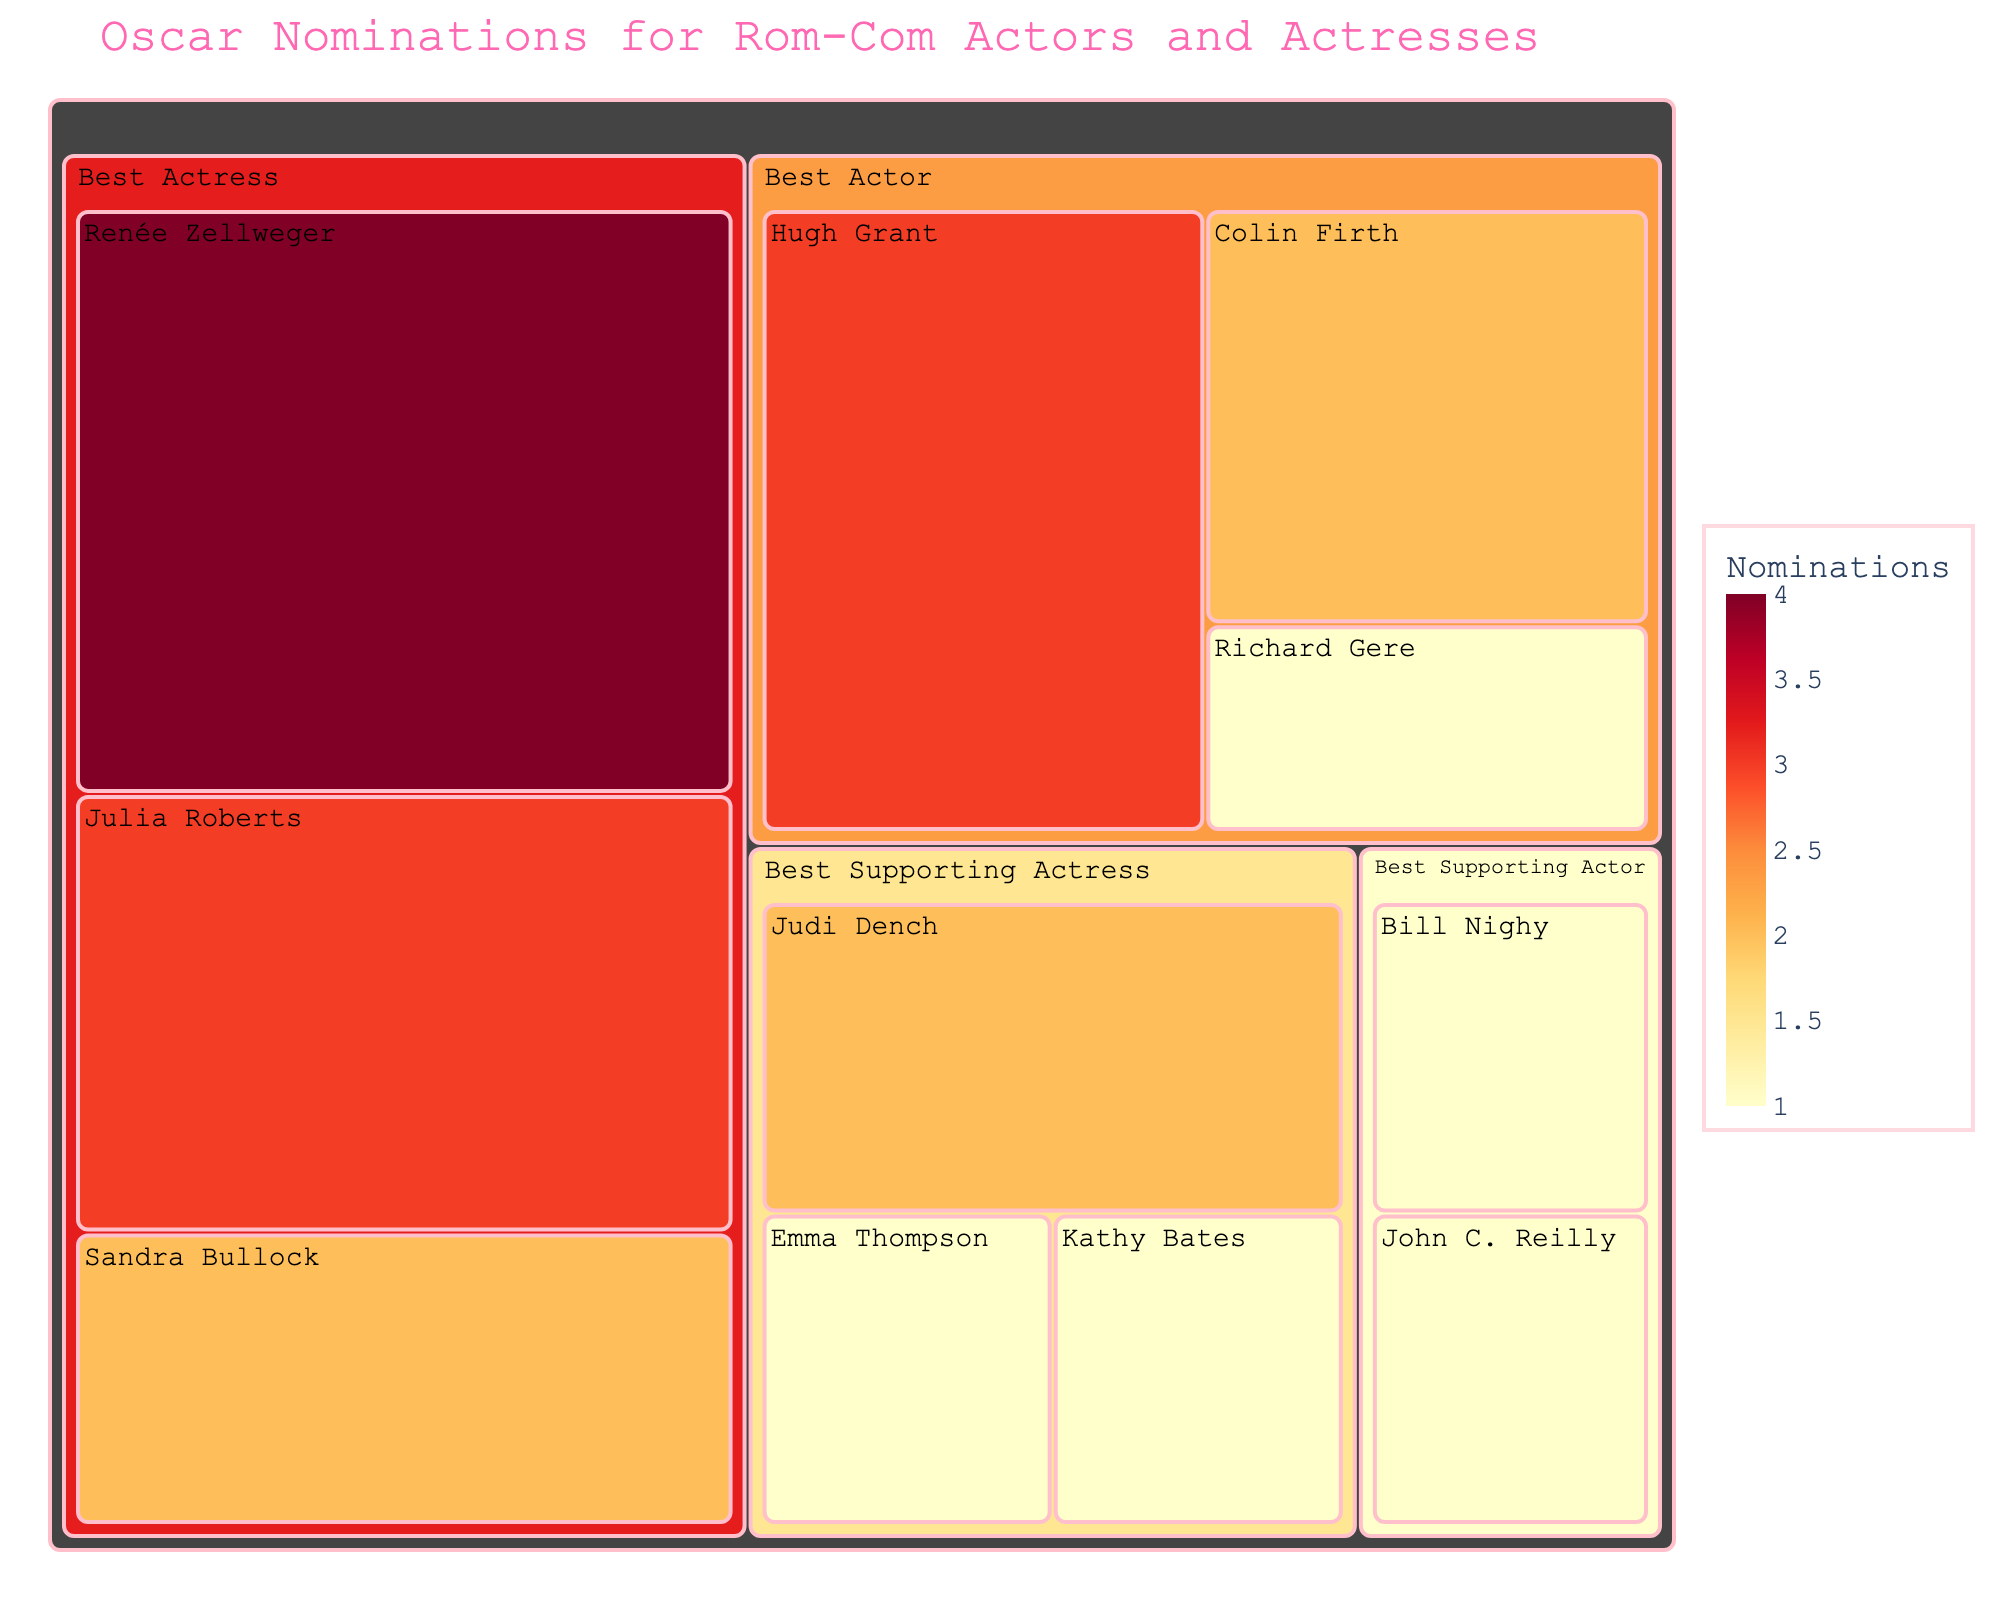What's the title of the figure? The title of the figure is prominently displayed at the top.
Answer: Oscar Nominations for Rom-Com Actors and Actresses Which category has the highest number of nominations in total? Add the nominations for each actor/actress per category. Best Actress: Renée Zellweger (4) + Julia Roberts (3) + Sandra Bullock (2) = 9. Best Actor: Hugh Grant (3) + Colin Firth (2) + Richard Gere (1) = 6. Best Supporting Actress: Judi Dench (2) + Emma Thompson (1) + Kathy Bates (1) = 4. Best Supporting Actor: Bill Nighy (1) + John C. Reilly (1) = 2. Therefore, the Best Actress category has the highest number of nominations.
Answer: Best Actress Who has the highest number of nominations among the Best Actor category? Look within the Best Actor category to see which actor has the highest number of nominations.
Answer: Hugh Grant How many nominations do Hugh Grant and Renée Zellweger have combined? Sum up the nominations for Hugh Grant (3) and Renée Zellweger (4).
Answer: 7 Which categories have exactly one nomination for an actor/actress? Check each category for actors/actresses who have only one nomination. Best Actor: Richard Gere. Best Supporting Actor: Bill Nighy, John C. Reilly. Best Supporting Actress: Emma Thompson, Kathy Bates. Therefore, Best Actor, Best Supporting Actor, and Best Supporting Actress have at least one nomination for an actor/actress.
Answer: Best Actor, Best Supporting Actor, Best Supporting Actress Who has more Oscar nominations: Julia Roberts or Judi Dench? Compare the nominations of Julia Roberts (3) and Judi Dench (2).
Answer: Julia Roberts What is the total number of nominations for the Best Supporting Actress category? Add up the nominations for each actress in the Best Supporting Actress category: Judi Dench (2) + Emma Thompson (1) + Kathy Bates (1).
Answer: 4 Which category has the fewest total nominations? Sum up the nominations for each category and find the smallest total. Best Actor: 6, Best Actress: 9, Best Supporting Actor: 2, Best Supporting Actress: 4.
Answer: Best Supporting Actor How many actors/actresses have received 3 or more nominations? Look to see which actors/actresses have 3 or more nominations: Renée Zellweger (4), Julia Roberts (3), Hugh Grant (3).
Answer: 3 actresses Between actors in the Best Actor category, who has the least number of nominations? Look within the Best Actor category to see which actor has the fewest nominations.
Answer: Richard Gere 